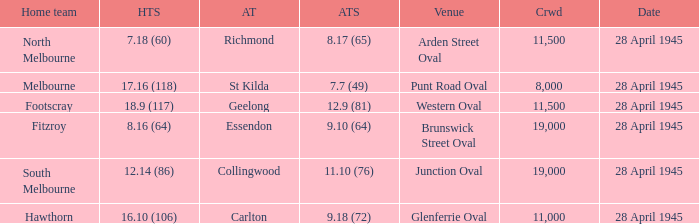What home team has an Away team of richmond? North Melbourne. 